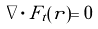Convert formula to latex. <formula><loc_0><loc_0><loc_500><loc_500>\nabla \cdot F _ { t } ( r ) = 0</formula> 